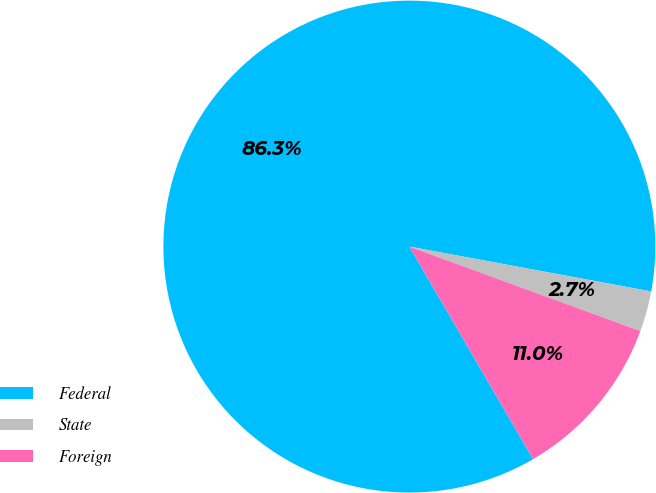<chart> <loc_0><loc_0><loc_500><loc_500><pie_chart><fcel>Federal<fcel>State<fcel>Foreign<nl><fcel>86.31%<fcel>2.66%<fcel>11.03%<nl></chart> 